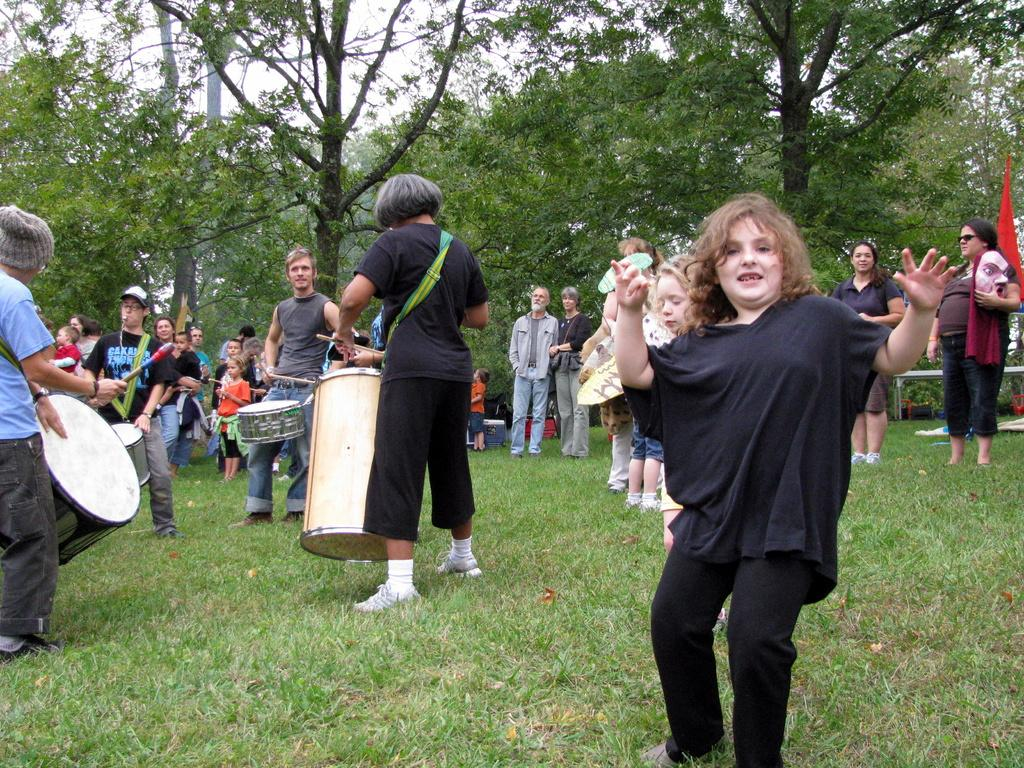How many people are in the image? There is a group of persons in the image. Where are the persons located in the image? The persons are standing on the floor at the left side of the image. What are the persons doing in the image? The persons are beating drums. What can be seen in the background of the image? There are trees in the background of the image. What type of bears can be seen solving arithmetic problems in the image? There are no bears or arithmetic problems present in the image; it features a group of persons beating drums. Can you tell me how many bikes are visible in the image? There are no bikes visible in the image. 